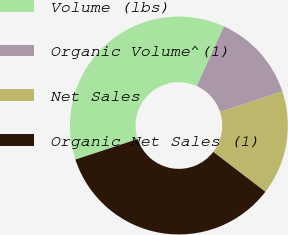Convert chart to OTSL. <chart><loc_0><loc_0><loc_500><loc_500><pie_chart><fcel>Volume (lbs)<fcel>Organic Volume^(1)<fcel>Net Sales<fcel>Organic Net Sales (1)<nl><fcel>36.84%<fcel>13.16%<fcel>15.46%<fcel>34.54%<nl></chart> 